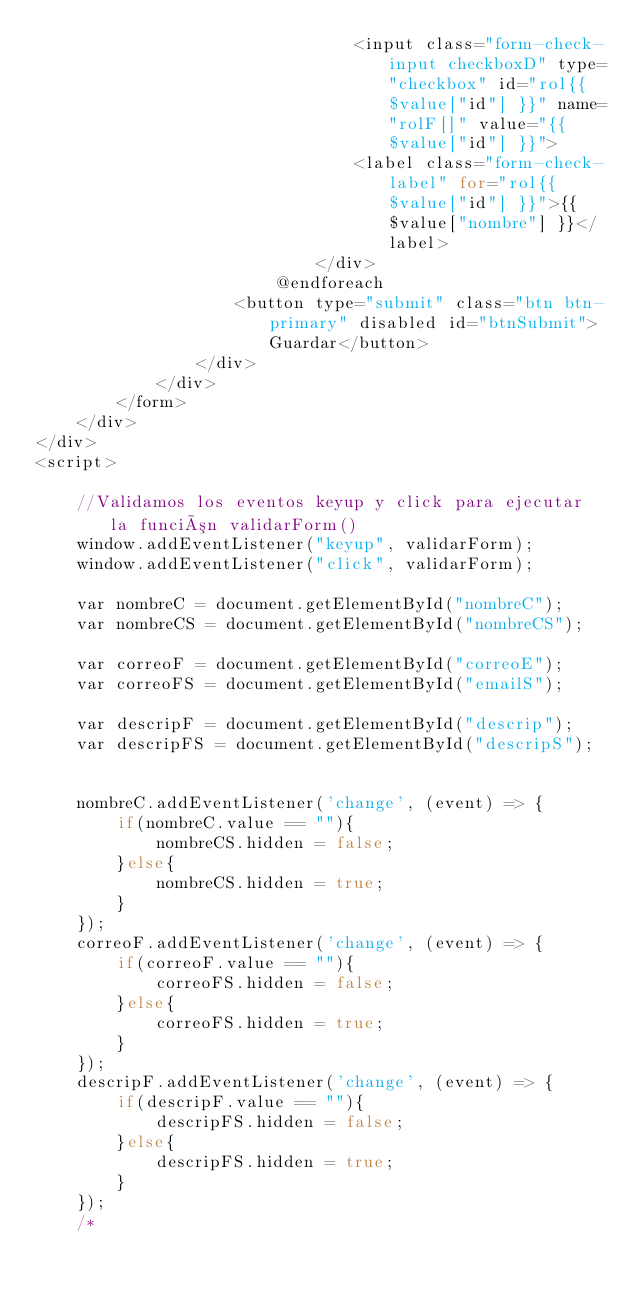Convert code to text. <code><loc_0><loc_0><loc_500><loc_500><_PHP_>                                <input class="form-check-input checkboxD" type="checkbox" id="rol{{ $value["id"] }}" name="rolF[]" value="{{ $value["id"] }}">
                                <label class="form-check-label" for="rol{{ $value["id"] }}">{{ $value["nombre"] }}</label>
                            </div>
                        @endforeach
                    <button type="submit" class="btn btn-primary" disabled id="btnSubmit">Guardar</button>
                </div>
            </div>
        </form>
    </div>
</div>
<script>

    //Validamos los eventos keyup y click para ejecutar la función validarForm()
    window.addEventListener("keyup", validarForm);
    window.addEventListener("click", validarForm);

    var nombreC = document.getElementById("nombreC");
    var nombreCS = document.getElementById("nombreCS");

    var correoF = document.getElementById("correoE");
    var correoFS = document.getElementById("emailS");

    var descripF = document.getElementById("descrip");
    var descripFS = document.getElementById("descripS");


    nombreC.addEventListener('change', (event) => {
        if(nombreC.value == ""){
            nombreCS.hidden = false;
        }else{
            nombreCS.hidden = true;
        }
    });
    correoF.addEventListener('change', (event) => {
        if(correoF.value == ""){
            correoFS.hidden = false;
        }else{
            correoFS.hidden = true;
        }
    });
    descripF.addEventListener('change', (event) => {
        if(descripF.value == ""){
            descripFS.hidden = false;
        }else{
            descripFS.hidden = true;
        }
    });
    /*</code> 